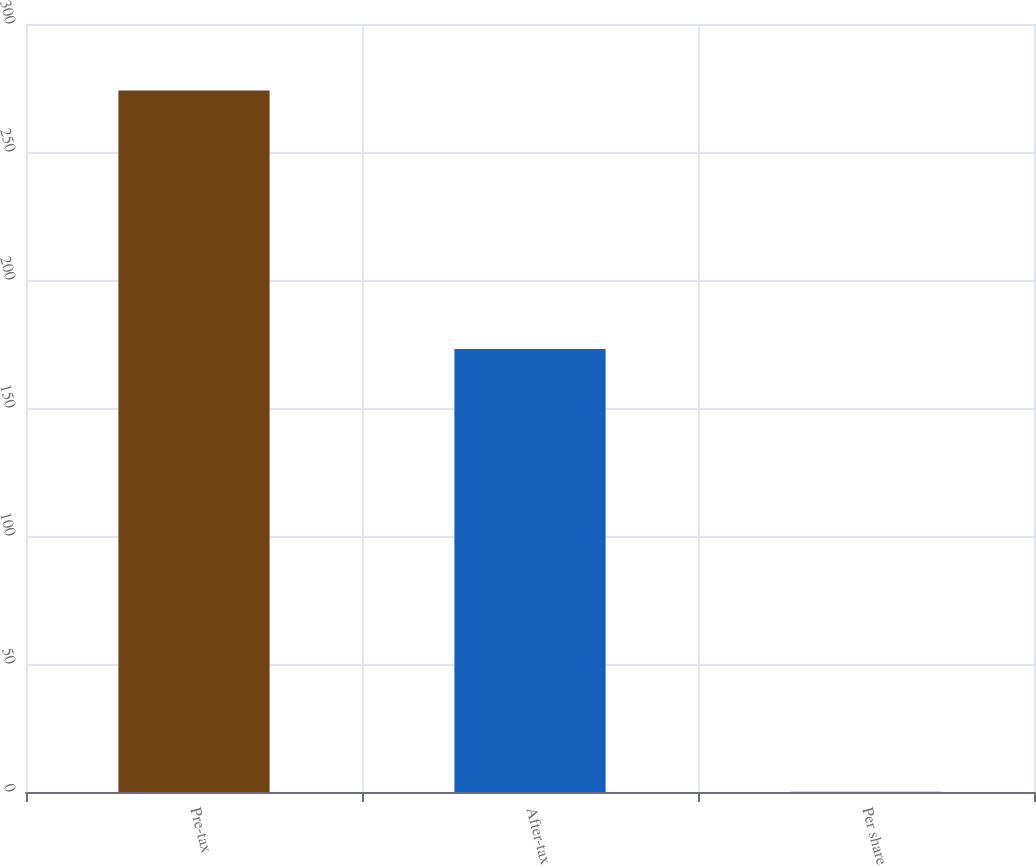<chart> <loc_0><loc_0><loc_500><loc_500><bar_chart><fcel>Pre-tax<fcel>After-tax<fcel>Per share<nl><fcel>274<fcel>173<fcel>0.11<nl></chart> 